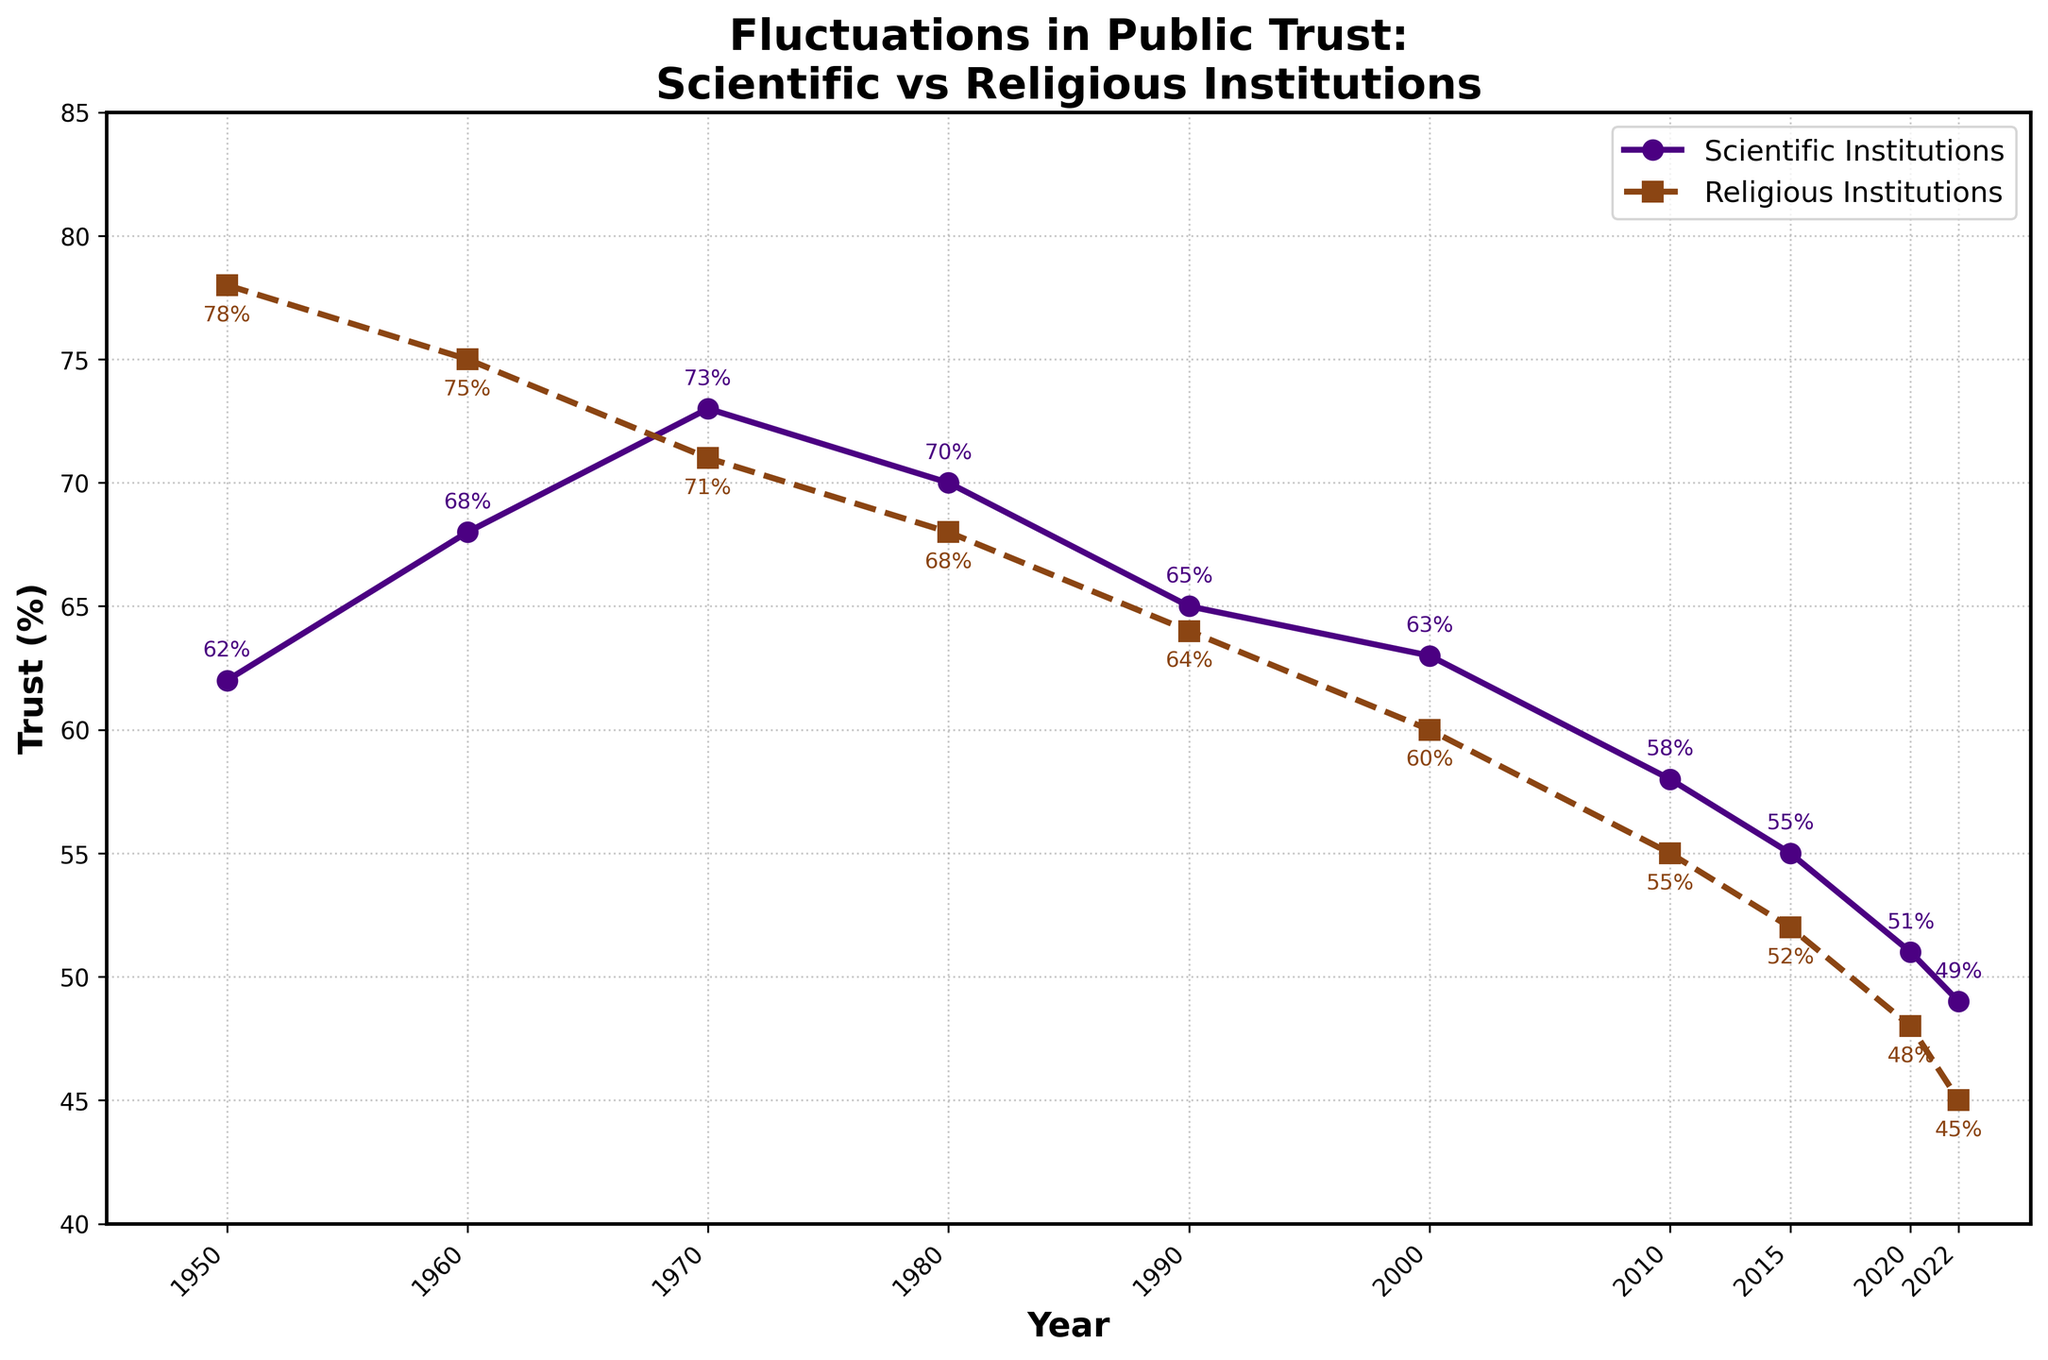what is the trend of trust in scientific institutions from 1950 to 2022? From the figure, we observe the trend line for scientific institutions, which starts at 62% in 1950 and shows a general downward trend, reaching 49% in 2022. We note fluctuations, but overall it declines.
Answer: downward compare the trust levels in scientific and religious institutions in the year 1950 From the 1950 plot points, trust in scientific institutions is 62% and that in religious institutions is 78%. Comparing these values, trust in religious institutions is higher.
Answer: trust in religious institutions is higher by how many percentage points did trust in scientific institutions decrease between 1970 and 2022? Trust in scientific institutions was 73% in 1970 and 49% in 2022. To calculate the decrease: 73% - 49% = 24 percentage points.
Answer: 24 compare the rate of decline in trust for both institutions from 2010 to 2022 In 2010, trust in scientific institutions was 58% and in 2022 it was 49%, a decrease of 9 percentage points. For religious institutions, trust decreased from 55% in 2010 to 45% in 2022, a decrease of 10 percentage points.
Answer: scientific: 9, religious: 10 what was the highest trust level for scientific institutions shown in the figure? By looking at the graph points, the highest trust in scientific institutions is at 73% in 1970.
Answer: 73% what is the difference in trust levels between scientific and religious institutions in 2022? From the plot points for 2022, trust in scientific institutions is 49% and in religious institutions is 45%. The difference is 49% - 45% = 4 percentage points.
Answer: 4 during which decade was the trust in religious institutions closest to the trust in scientific institutions? Reviewing the graph, in the 1990s, trust in scientific institutions was 65% and in religious institutions was 64%, showing the smallest difference.
Answer: 1990s which color represents the trust in scientific institutions in the figure? The figure shows that the trust in scientific institutions is represented by the color indigo.
Answer: indigo how many percentage points did the trust in religious institutions decrease from 1950 to 2000? Trust in religious institutions was 78% in 1950 and 60% in 2000. The decrease is 78% - 60% = 18 percentage points.
Answer: 18 what can you infer about the public's overall trust in institutions from 1950 to 2022? Both lines show a general decline, suggesting that the public's trust in both scientific and religious institutions has decreased over time.
Answer: decreasing trust 